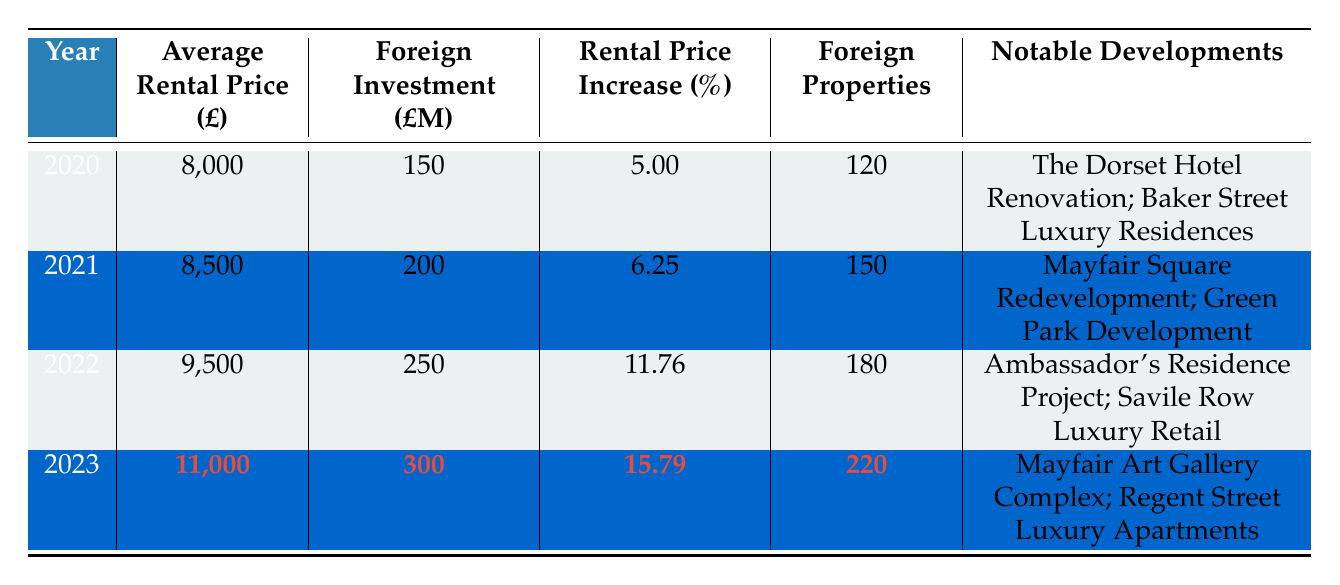What was the average rental price in 2022? The table shows that the average rental price in 2022 is listed as 9,500.
Answer: 9,500 How much foreign investment was made in Mayfair in 2021? Referring to the table, the foreign investment amount for 2021 is recorded as £200 million.
Answer: 200 million Which year experienced the highest percentage increase in rental prices? By comparing the "Rental Price Increase (%)" column, the year 2023 shows the highest increase at 15.79%.
Answer: 2023 What are the notable developments for 2023? The notable developments listed for 2023 include "Mayfair Art Gallery Complex" and "Regent Street Luxury Apartments."
Answer: Mayfair Art Gallery Complex; Regent Street Luxury Apartments How many foreign properties were there in Mayfair in 2020 compared to 2023? In 2020, there were 120 foreign properties, and in 2023, there were 220. The difference is 220 - 120 = 100 more foreign properties in 2023.
Answer: 100 more What was the total foreign investment amount from 2020 to 2023? The foreign investment amounts are 150 million (2020), 200 million (2021), 250 million (2022), and 300 million (2023). Summing these gives 150 + 200 + 250 + 300 = 900 million.
Answer: 900 million In which year did the average rental price exceed £10,000? According to the table, the average rental price exceeded £10,000 in 2023, where it is listed as 11,000.
Answer: 2023 How much did the average rental price increase from 2021 to 2022? The average rental price in 2021 was 8,500 and in 2022 it was 9,500. The increase is 9,500 - 8,500 = 1,000.
Answer: 1,000 Is there a correlation between foreign investment and the average rental price? By observing the table, each year shows an increase in both foreign investment and average rental price. Therefore, a positive correlation can be inferred.
Answer: Yes What was the percentage increase in rental price from 2020 to 2023? The rental price in 2020 was 8,000 and in 2023 it reached 11,000. The percentage increase is calculated as ((11,000 - 8,000) / 8,000) * 100 = 37.5%.
Answer: 37.5% 